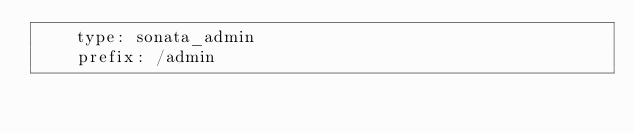Convert code to text. <code><loc_0><loc_0><loc_500><loc_500><_YAML_>    type: sonata_admin
    prefix: /admin
</code> 